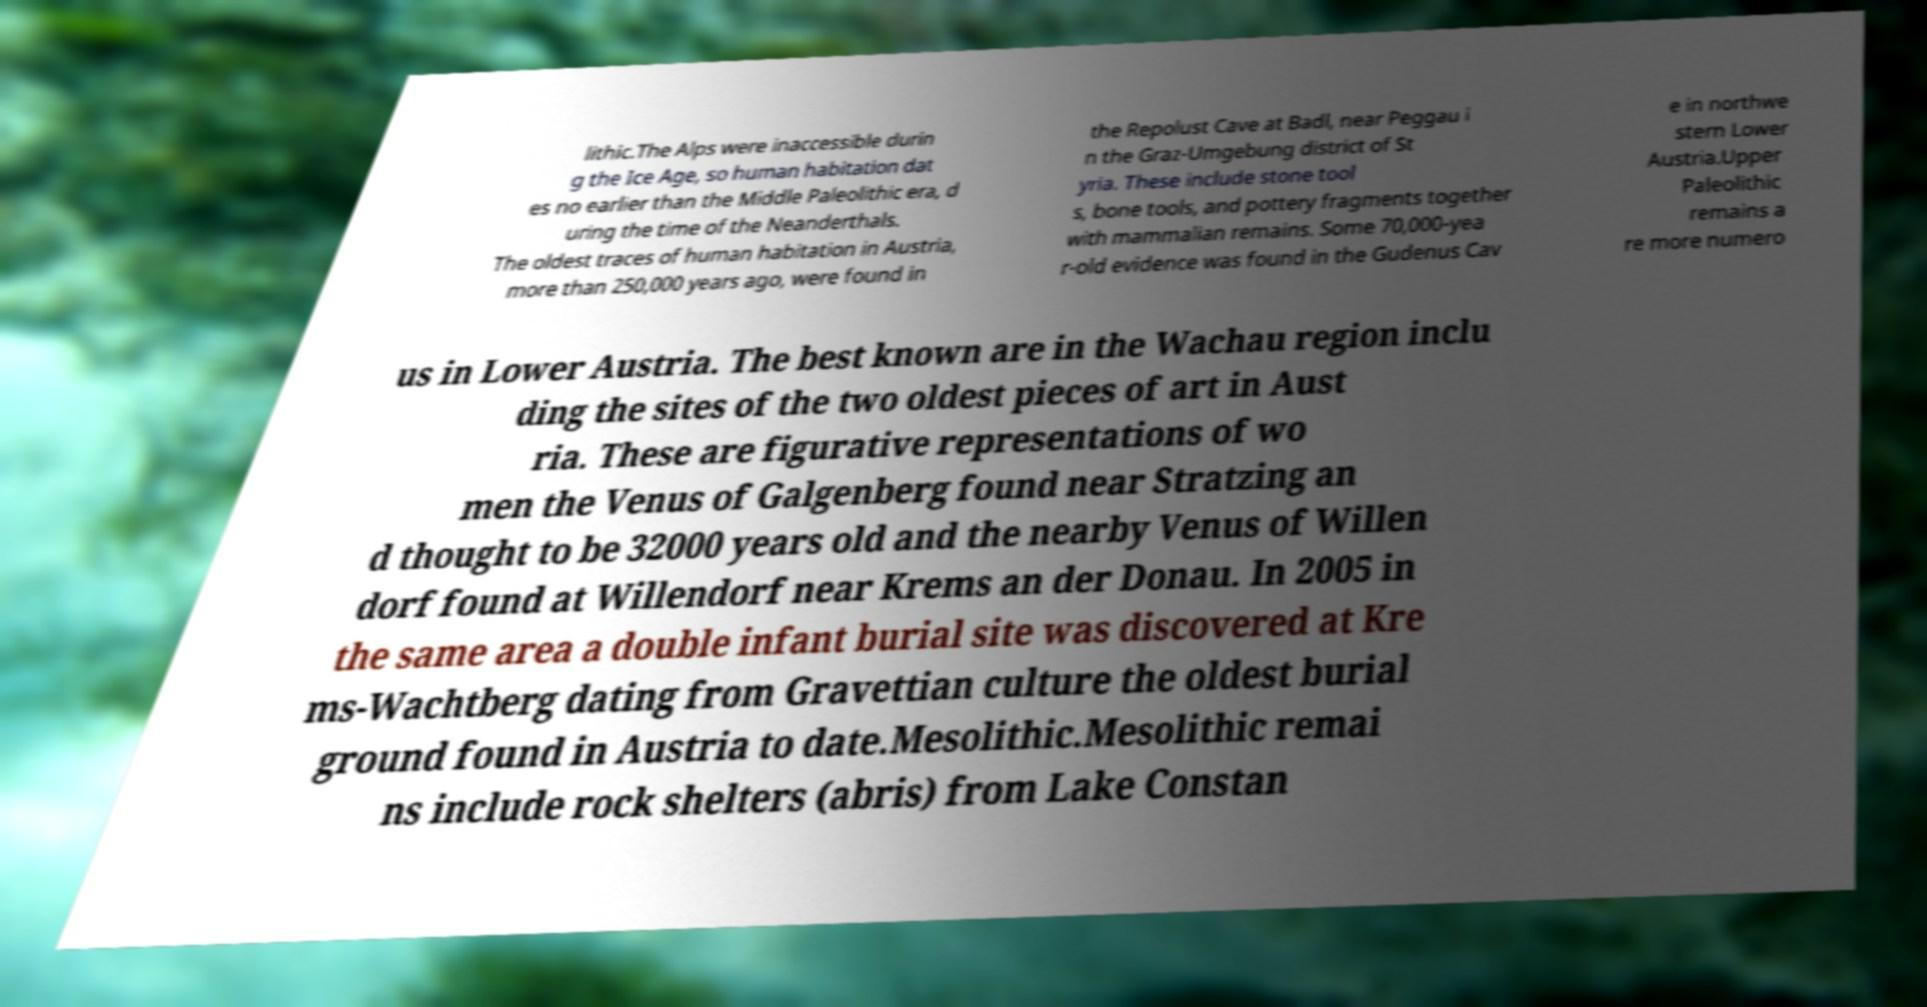Can you accurately transcribe the text from the provided image for me? lithic.The Alps were inaccessible durin g the Ice Age, so human habitation dat es no earlier than the Middle Paleolithic era, d uring the time of the Neanderthals. The oldest traces of human habitation in Austria, more than 250,000 years ago, were found in the Repolust Cave at Badl, near Peggau i n the Graz-Umgebung district of St yria. These include stone tool s, bone tools, and pottery fragments together with mammalian remains. Some 70,000-yea r-old evidence was found in the Gudenus Cav e in northwe stern Lower Austria.Upper Paleolithic remains a re more numero us in Lower Austria. The best known are in the Wachau region inclu ding the sites of the two oldest pieces of art in Aust ria. These are figurative representations of wo men the Venus of Galgenberg found near Stratzing an d thought to be 32000 years old and the nearby Venus of Willen dorf found at Willendorf near Krems an der Donau. In 2005 in the same area a double infant burial site was discovered at Kre ms-Wachtberg dating from Gravettian culture the oldest burial ground found in Austria to date.Mesolithic.Mesolithic remai ns include rock shelters (abris) from Lake Constan 